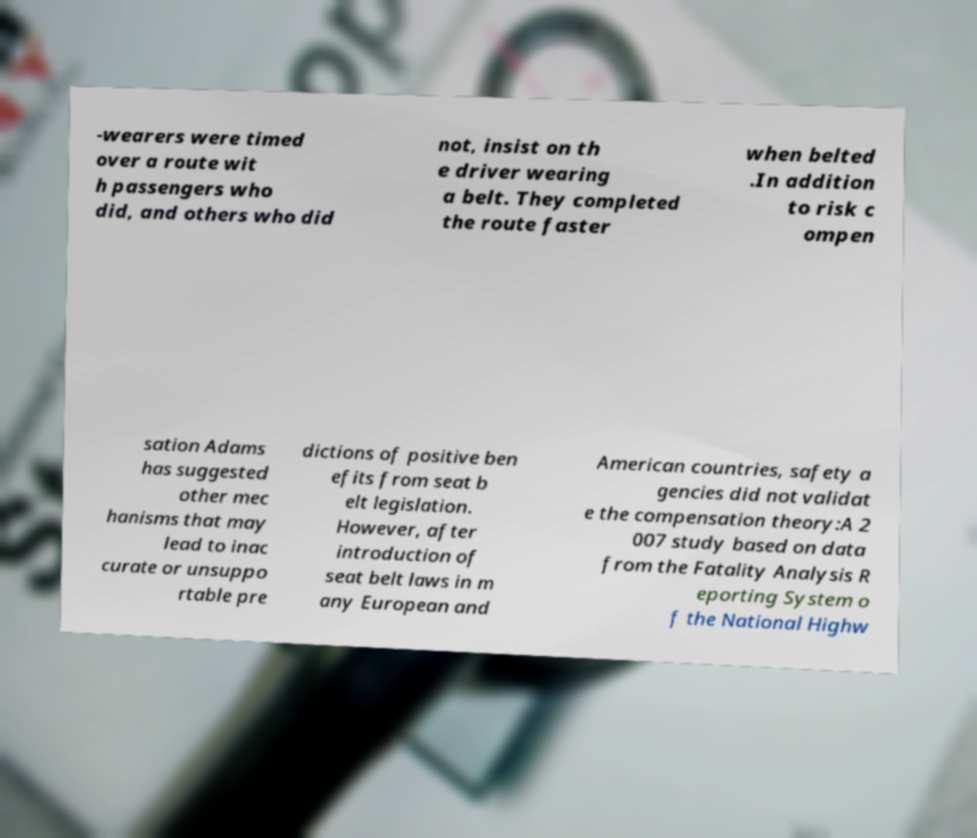Please identify and transcribe the text found in this image. -wearers were timed over a route wit h passengers who did, and others who did not, insist on th e driver wearing a belt. They completed the route faster when belted .In addition to risk c ompen sation Adams has suggested other mec hanisms that may lead to inac curate or unsuppo rtable pre dictions of positive ben efits from seat b elt legislation. However, after introduction of seat belt laws in m any European and American countries, safety a gencies did not validat e the compensation theory:A 2 007 study based on data from the Fatality Analysis R eporting System o f the National Highw 